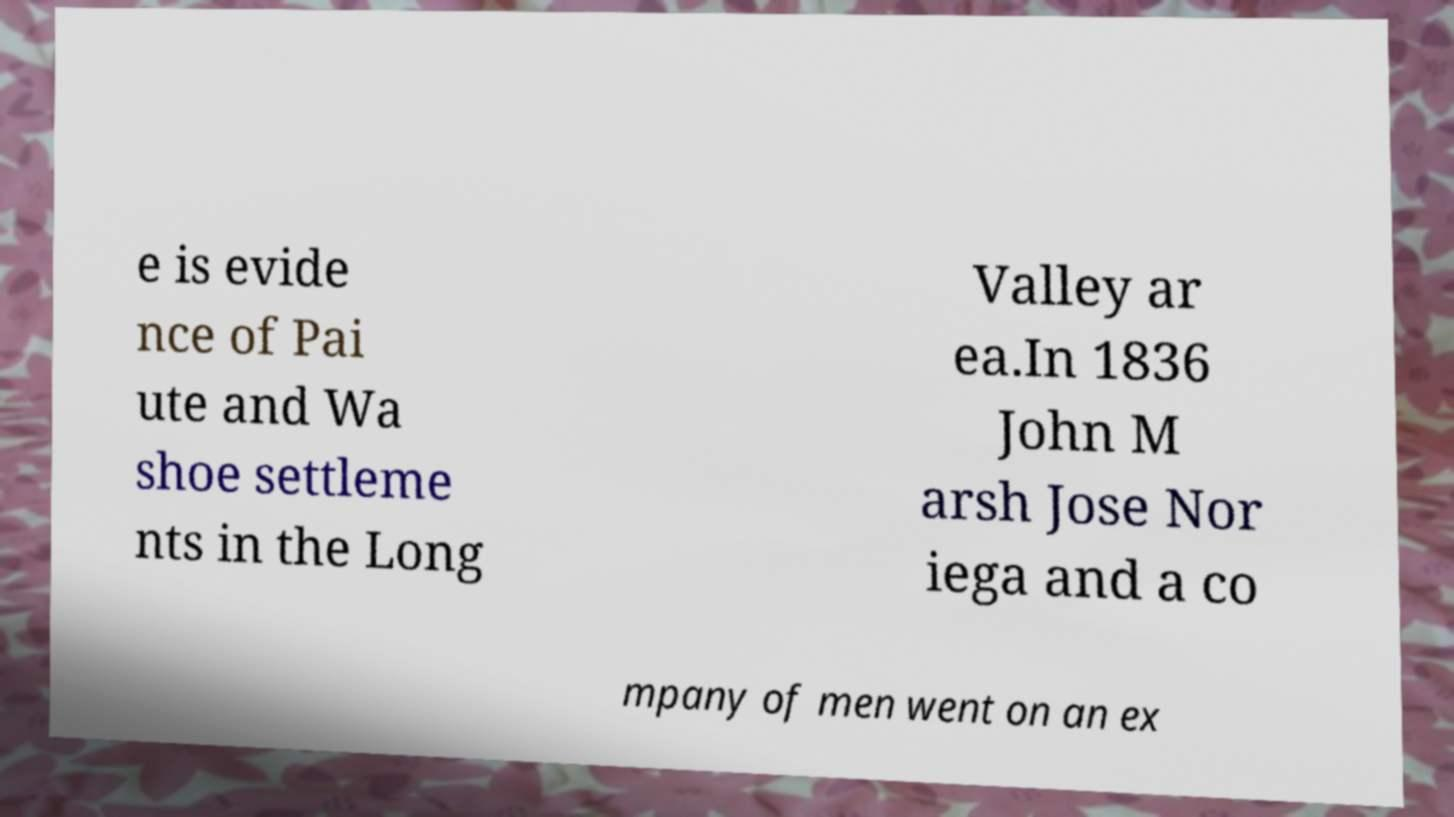I need the written content from this picture converted into text. Can you do that? e is evide nce of Pai ute and Wa shoe settleme nts in the Long Valley ar ea.In 1836 John M arsh Jose Nor iega and a co mpany of men went on an ex 